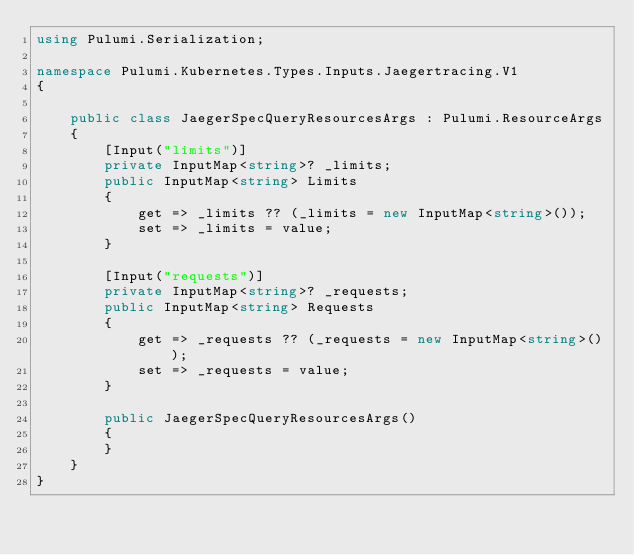Convert code to text. <code><loc_0><loc_0><loc_500><loc_500><_C#_>using Pulumi.Serialization;

namespace Pulumi.Kubernetes.Types.Inputs.Jaegertracing.V1
{

    public class JaegerSpecQueryResourcesArgs : Pulumi.ResourceArgs
    {
        [Input("limits")]
        private InputMap<string>? _limits;
        public InputMap<string> Limits
        {
            get => _limits ?? (_limits = new InputMap<string>());
            set => _limits = value;
        }

        [Input("requests")]
        private InputMap<string>? _requests;
        public InputMap<string> Requests
        {
            get => _requests ?? (_requests = new InputMap<string>());
            set => _requests = value;
        }

        public JaegerSpecQueryResourcesArgs()
        {
        }
    }
}
</code> 